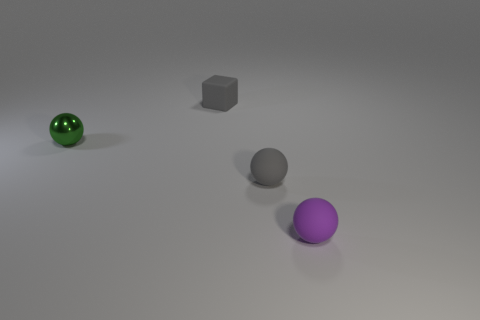There is a sphere that is to the left of the purple rubber thing and to the right of the tiny green shiny thing; what is its size? The sphere in question appears to be of a modest size, significantly smaller than the purple rubber object to its right but larger than the tiny green glossy object to its left. Its size can be best described as medium in comparison to the objects nearby. 